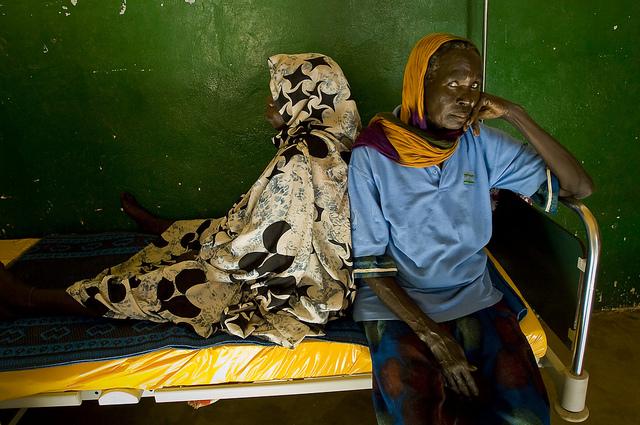What piece of furniture are the women sitting on?
Be succinct. Bed. Are the whites of the eyes particularly noticeable, here?
Short answer required. Yes. What color is the woman shirt?
Quick response, please. Blue. 